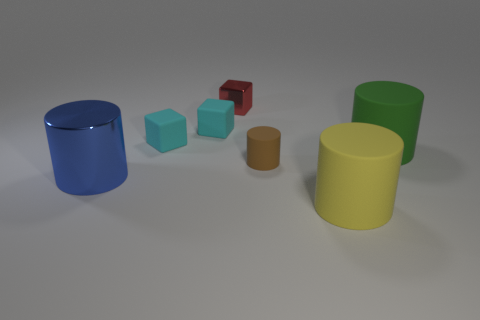Is there any other thing that is the same size as the red cube?
Your answer should be very brief. Yes. How many matte things are large blue things or brown objects?
Provide a succinct answer. 1. Are there any small gray cylinders?
Your answer should be very brief. No. What is the color of the big cylinder that is in front of the shiny object that is in front of the green rubber cylinder?
Your response must be concise. Yellow. What number of other objects are the same color as the small metallic block?
Offer a terse response. 0. How many objects are either red objects or things that are behind the large yellow matte cylinder?
Provide a short and direct response. 6. The shiny object that is right of the blue object is what color?
Keep it short and to the point. Red. There is a small red shiny object; what shape is it?
Provide a succinct answer. Cube. The big cylinder behind the big object left of the big yellow rubber thing is made of what material?
Keep it short and to the point. Rubber. How many other things are the same material as the red cube?
Offer a very short reply. 1. 